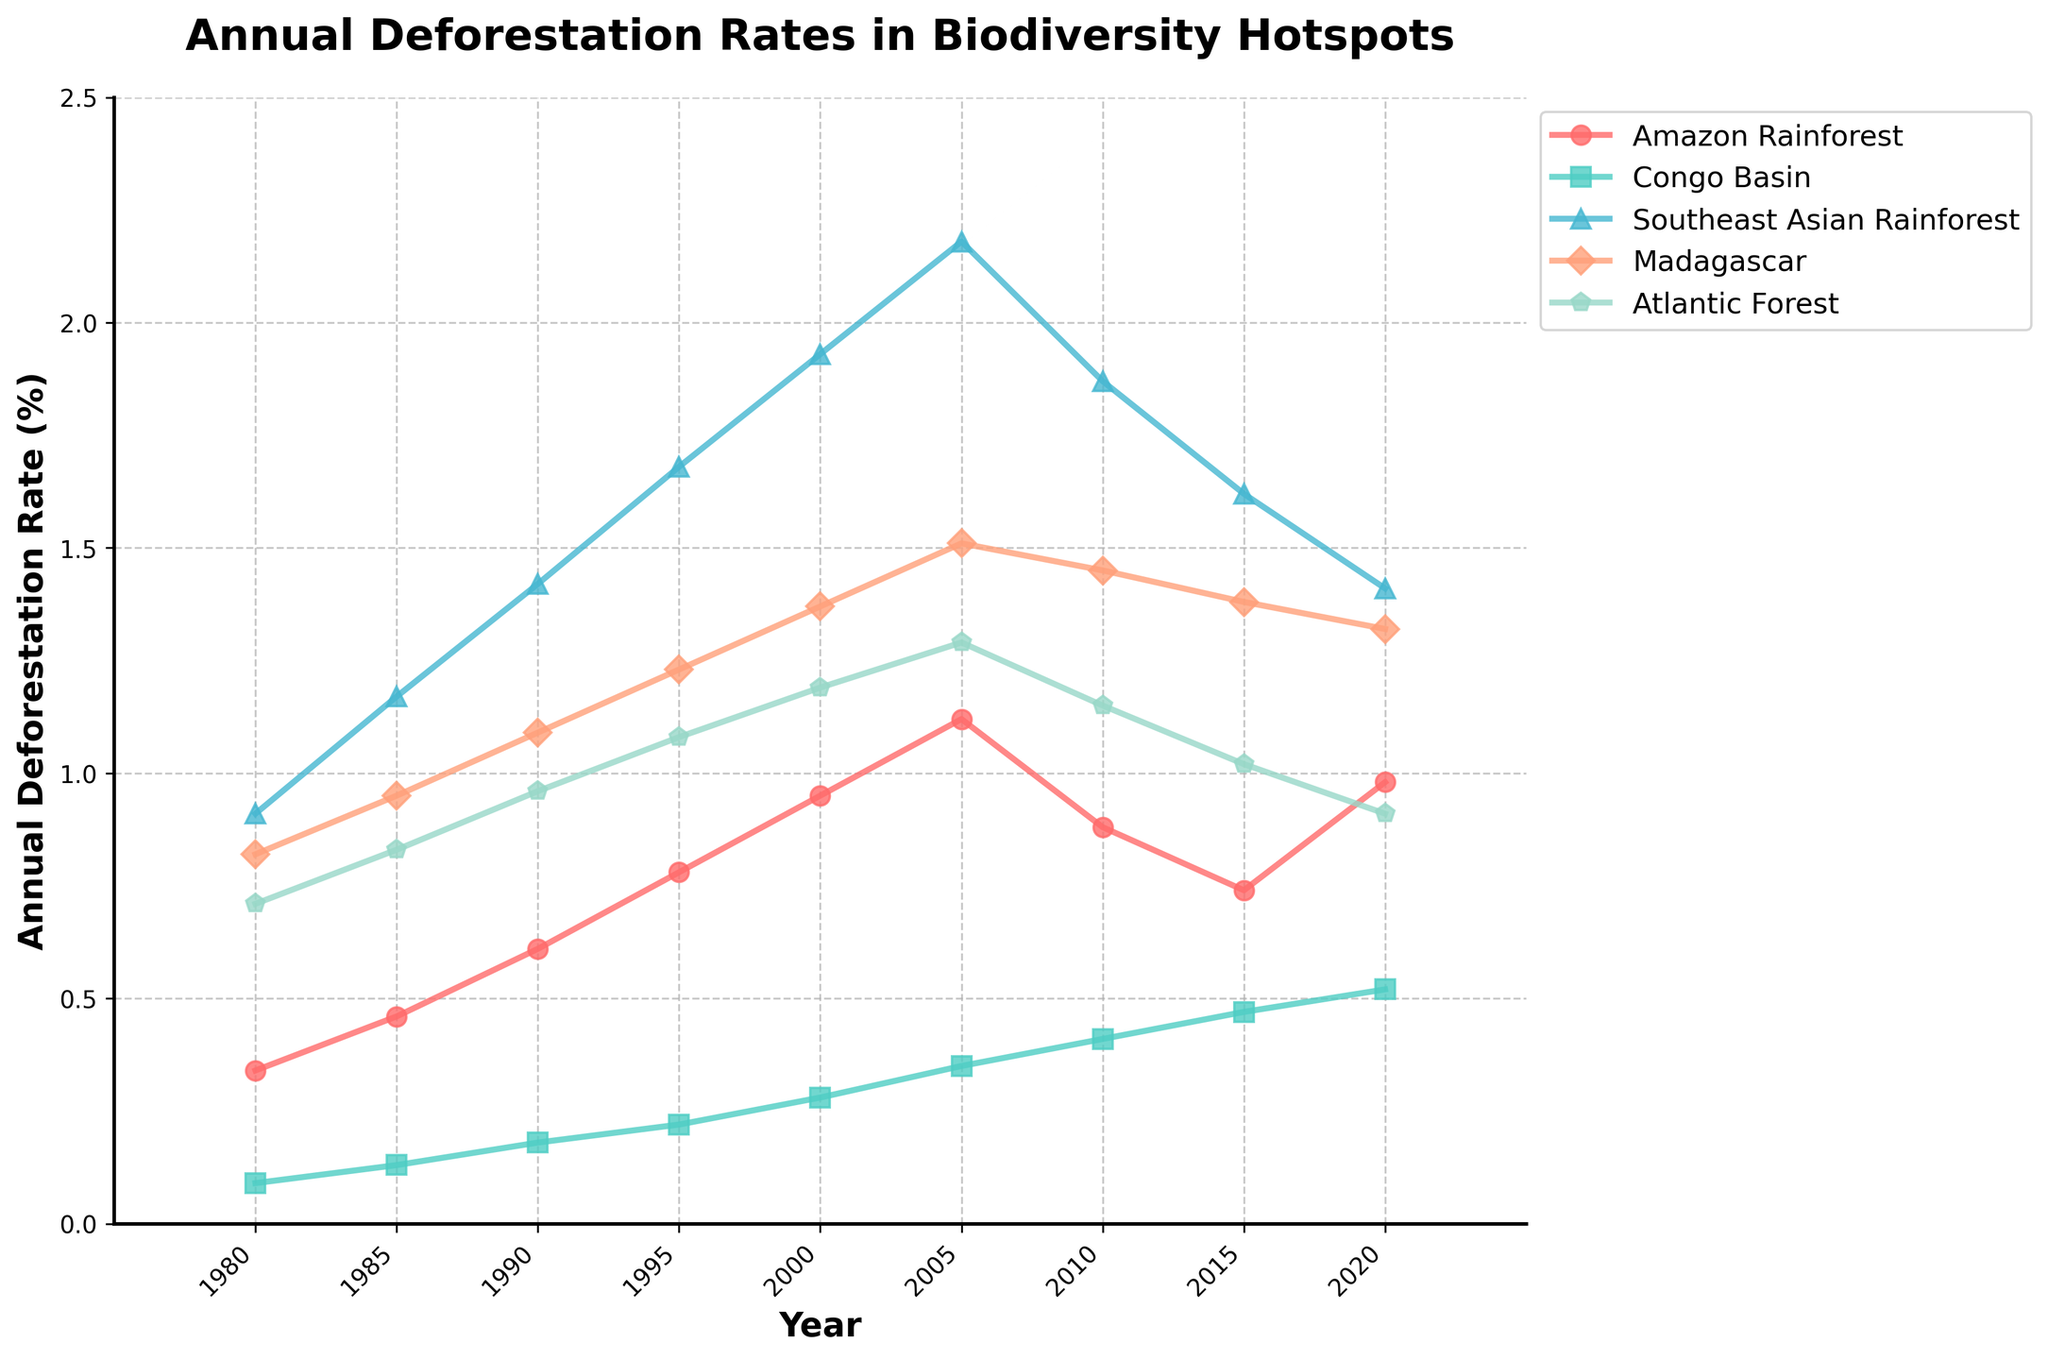What year did the Amazon Rainforest experience the highest annual deforestation rate? The highest value for the Amazon Rainforest is at the peak of its line plot, which corresponds to the year 2005.
Answer: 2005 How does the deforestation rate in the Atlantic Forest in 2010 compare to that in 2020? The line for the Atlantic Forest is at approximately 1.15% in 2010 and drops to about 0.91% in 2020, indicating a decrease.
Answer: Decreased Which biodiversity hotspot shows the most consistent increase in deforestation rates from 1980 to 2020? By observing the trends over the years, the Congo Basin shows a steady increase from 0.09% in 1980 to 0.52% in 2020 without any major dips.
Answer: Congo Basin What is the average deforestation rate for the Southeast Asian Rainforest over the period shown? Sum of Southeast Asian Rainforest rates over the years (0.91 + 1.17 + 1.42 + 1.68 + 1.93 + 2.18 + 1.87 + 1.62 + 1.41) = 14.19. Divide by 9 (number of years) to get the average: 14.19/9 = 1.576.
Answer: 1.58 Which hotspot experienced a deforestation rate of approximately 0.28% in the year 2000? By matching the value to the year 2000 in the graph, the Congo Basin had a deforestation rate of 0.28%.
Answer: Congo Basin During which period did Madagascar's deforestation rate peak, and what was the rate? The highest point on the line for Madagascar corresponds to shortly after the year 2000, at around 1.51%.
Answer: 2005, 1.51% Compare the deforestation rate in the Amazon Rainforest from 1985 to 1990. Did the rate more than double? The Amazon Rainforest's rate is 0.46% in 1985 and 0.61% in 1990. Doubling 0.46% would be 0.92%, so no, it did not more than double.
Answer: No What color is used to represent the deforestation rate in the Atlantic Forest? The line representing the Atlantic Forest is shaded in green color.
Answer: Green What is the difference in deforestation rates between the Amazon Rainforest and the Atlantic Forest in 2015? Amazon Rainforest (2015) = 0.74%, Atlantic Forest (2015) = 1.02%, Difference = 1.02% - 0.74% = 0.28%.
Answer: 0.28% Which biodiversity hotspot shows a decrease in deforestation from 2005 to 2010, and by how much? The Amazon Rainforest drops from 1.12% in 2005 to 0.88% in 2010, showing a decrease of 1.12% - 0.88% = 0.24%.
Answer: Amazon Rainforest, 0.24% 